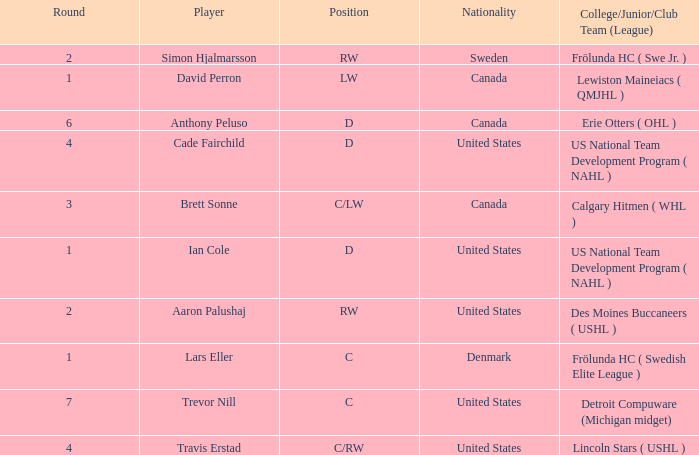Who is the player from Denmark who plays position c? Lars Eller. Can you give me this table as a dict? {'header': ['Round', 'Player', 'Position', 'Nationality', 'College/Junior/Club Team (League)'], 'rows': [['2', 'Simon Hjalmarsson', 'RW', 'Sweden', 'Frölunda HC ( Swe Jr. )'], ['1', 'David Perron', 'LW', 'Canada', 'Lewiston Maineiacs ( QMJHL )'], ['6', 'Anthony Peluso', 'D', 'Canada', 'Erie Otters ( OHL )'], ['4', 'Cade Fairchild', 'D', 'United States', 'US National Team Development Program ( NAHL )'], ['3', 'Brett Sonne', 'C/LW', 'Canada', 'Calgary Hitmen ( WHL )'], ['1', 'Ian Cole', 'D', 'United States', 'US National Team Development Program ( NAHL )'], ['2', 'Aaron Palushaj', 'RW', 'United States', 'Des Moines Buccaneers ( USHL )'], ['1', 'Lars Eller', 'C', 'Denmark', 'Frölunda HC ( Swedish Elite League )'], ['7', 'Trevor Nill', 'C', 'United States', 'Detroit Compuware (Michigan midget)'], ['4', 'Travis Erstad', 'C/RW', 'United States', 'Lincoln Stars ( USHL )']]} 